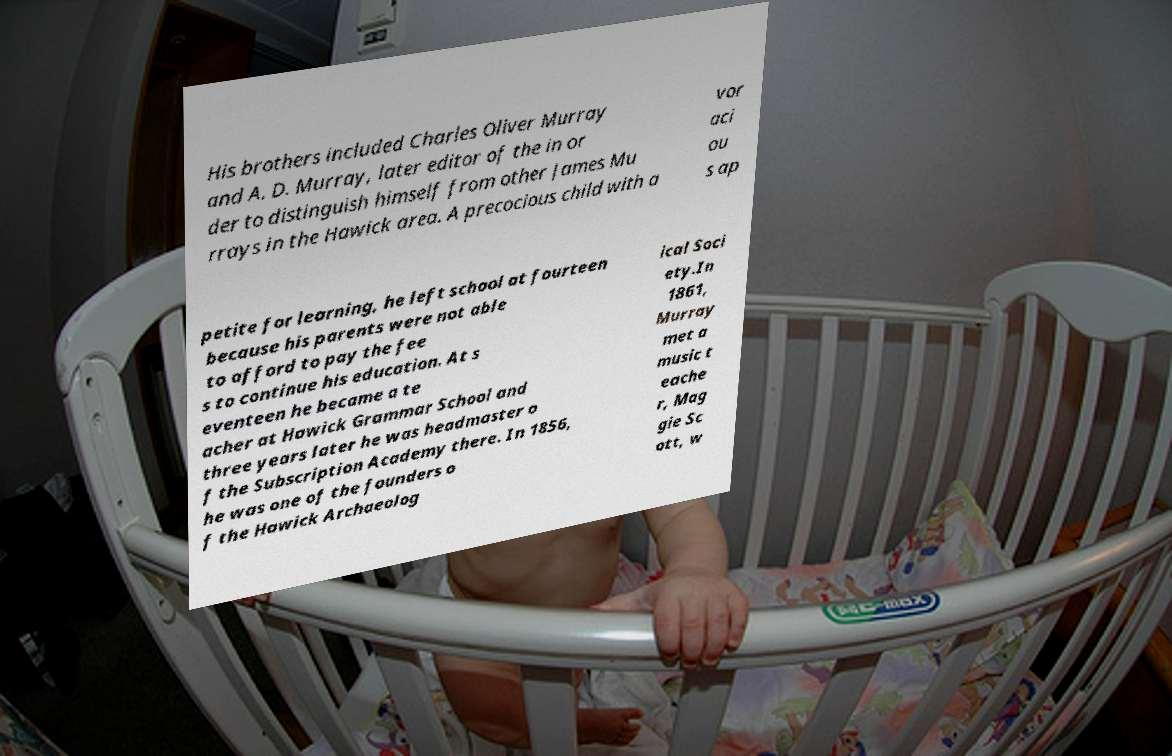Can you read and provide the text displayed in the image?This photo seems to have some interesting text. Can you extract and type it out for me? His brothers included Charles Oliver Murray and A. D. Murray, later editor of the in or der to distinguish himself from other James Mu rrays in the Hawick area. A precocious child with a vor aci ou s ap petite for learning, he left school at fourteen because his parents were not able to afford to pay the fee s to continue his education. At s eventeen he became a te acher at Hawick Grammar School and three years later he was headmaster o f the Subscription Academy there. In 1856, he was one of the founders o f the Hawick Archaeolog ical Soci ety.In 1861, Murray met a music t eache r, Mag gie Sc ott, w 